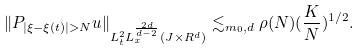Convert formula to latex. <formula><loc_0><loc_0><loc_500><loc_500>\| P _ { | \xi - \xi ( t ) | > N } u \| _ { L _ { t } ^ { 2 } L _ { x } ^ { \frac { 2 d } { d - 2 } } ( J \times R ^ { d } ) } \lesssim _ { m _ { 0 } , d } \rho ( N ) ( \frac { K } { N } ) ^ { 1 / 2 } .</formula> 